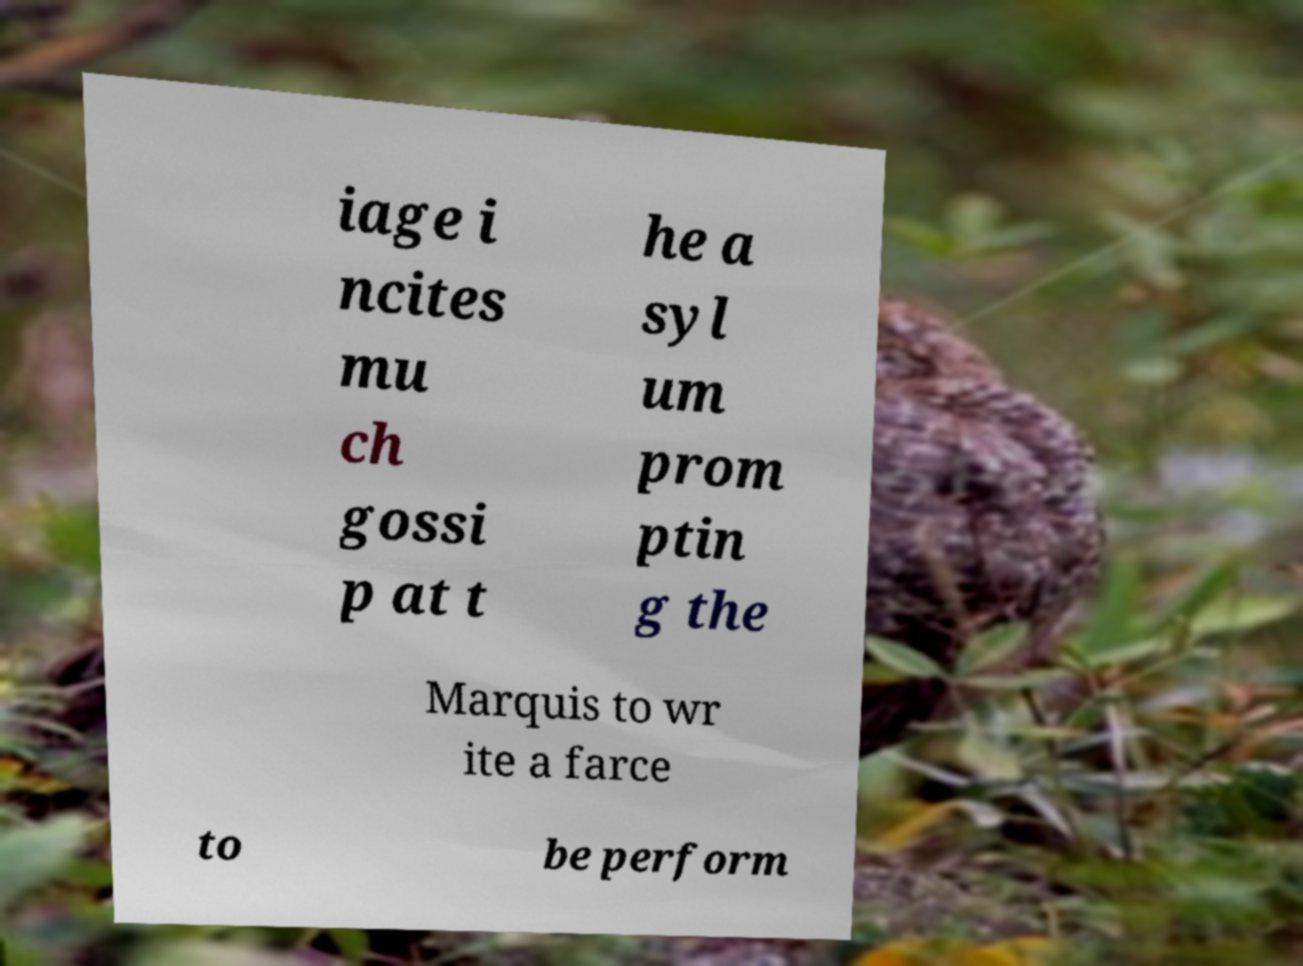Could you extract and type out the text from this image? iage i ncites mu ch gossi p at t he a syl um prom ptin g the Marquis to wr ite a farce to be perform 